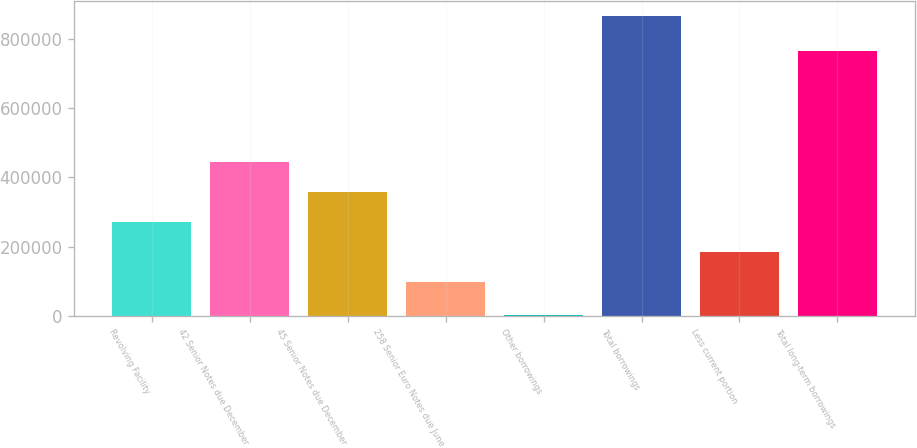<chart> <loc_0><loc_0><loc_500><loc_500><bar_chart><fcel>Revolving Facility<fcel>42 Senior Notes due December<fcel>45 Senior Notes due December<fcel>258 Senior Euro Notes due June<fcel>Other borrowings<fcel>Total borrowings<fcel>Less current portion<fcel>Total long-term borrowings<nl><fcel>270812<fcel>443169<fcel>356991<fcel>98456<fcel>2170<fcel>863952<fcel>184634<fcel>765006<nl></chart> 